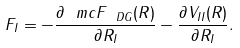Convert formula to latex. <formula><loc_0><loc_0><loc_500><loc_500>F _ { I } = - \frac { \partial \ m c { F } _ { \ D G } ( R ) } { \partial R _ { I } } - \frac { \partial V _ { I I } ( R ) } { \partial R _ { I } } .</formula> 